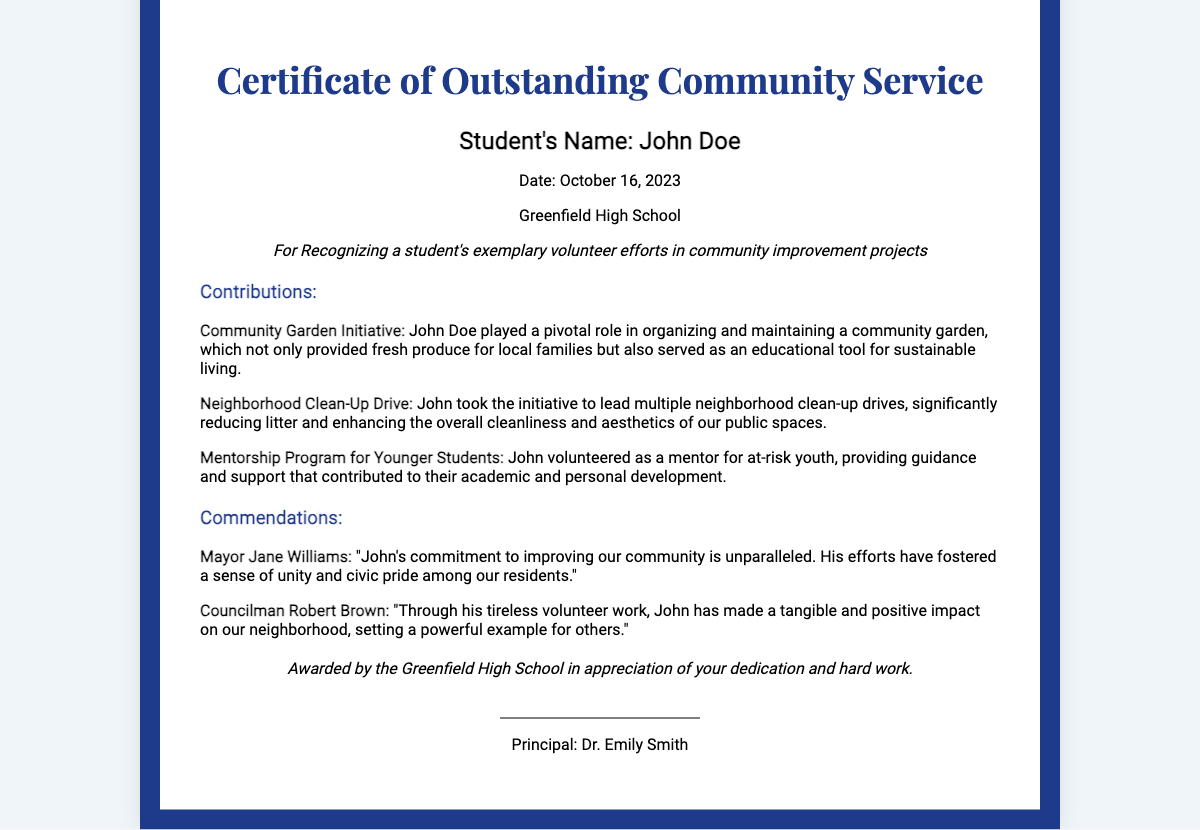What is the name of the student awarded? The name of the student awarded is displayed prominently in the "recipient" section of the document.
Answer: John Doe What is the date of the award? The date of the award is clearly listed in the document, under the student's name.
Answer: October 16, 2023 What school issued the certificate? The school issuing the certificate is mentioned in the document, identifying the institution.
Answer: Greenfield High School What initiative did John Doe contribute to? The document provides specific contributions made by the student, including initiatives that improved the community.
Answer: Community Garden Initiative Who commended John Doe for his contributions? The document includes quotes from local leaders who commend the student for his volunteer efforts.
Answer: Mayor Jane Williams How did John Doe impact neighborhood cleanliness? The document outlines his contributions regarding community efforts, specifically mentioning this aspect.
Answer: Neighborhood Clean-Up Drive What is the award for? The purpose of the certificate is explicitly stated in the description section of the document.
Answer: Exemplary volunteer efforts in community improvement projects Who is the principal that signed the certificate? The document includes the name of the principal who authorized the certificate, providing a formal acknowledgment.
Answer: Dr. Emily Smith What is one of the contributions listed in the certificate? The document specifies a particular contribution made by the student, showcasing various efforts made in the community.
Answer: Mentorship Program for Younger Students 